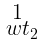<formula> <loc_0><loc_0><loc_500><loc_500>\begin{smallmatrix} 1 \\ \ w t _ { 2 } \end{smallmatrix}</formula> 